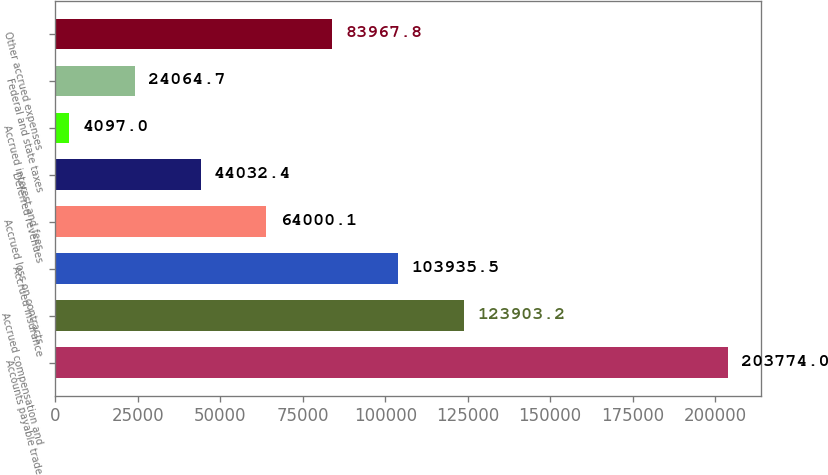Convert chart. <chart><loc_0><loc_0><loc_500><loc_500><bar_chart><fcel>Accounts payable trade<fcel>Accrued compensation and<fcel>Accrued insurance<fcel>Accrued loss on contracts<fcel>Deferred revenues<fcel>Accrued interest and fees<fcel>Federal and state taxes<fcel>Other accrued expenses<nl><fcel>203774<fcel>123903<fcel>103936<fcel>64000.1<fcel>44032.4<fcel>4097<fcel>24064.7<fcel>83967.8<nl></chart> 